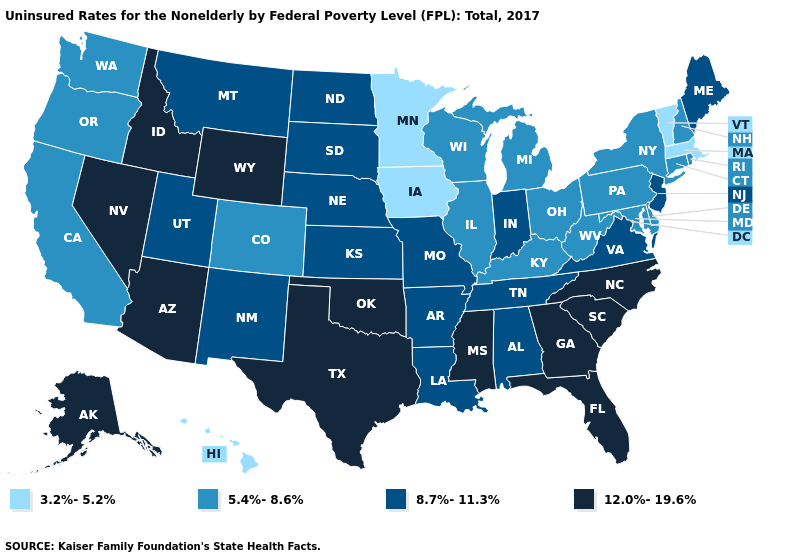What is the value of Hawaii?
Be succinct. 3.2%-5.2%. Name the states that have a value in the range 8.7%-11.3%?
Write a very short answer. Alabama, Arkansas, Indiana, Kansas, Louisiana, Maine, Missouri, Montana, Nebraska, New Jersey, New Mexico, North Dakota, South Dakota, Tennessee, Utah, Virginia. What is the highest value in the MidWest ?
Give a very brief answer. 8.7%-11.3%. Among the states that border Nebraska , does Iowa have the highest value?
Keep it brief. No. Name the states that have a value in the range 5.4%-8.6%?
Concise answer only. California, Colorado, Connecticut, Delaware, Illinois, Kentucky, Maryland, Michigan, New Hampshire, New York, Ohio, Oregon, Pennsylvania, Rhode Island, Washington, West Virginia, Wisconsin. Does Alabama have the highest value in the South?
Keep it brief. No. What is the value of Mississippi?
Be succinct. 12.0%-19.6%. Among the states that border Washington , does Idaho have the highest value?
Be succinct. Yes. Does Utah have a lower value than Florida?
Give a very brief answer. Yes. Which states have the lowest value in the West?
Answer briefly. Hawaii. What is the lowest value in the MidWest?
Write a very short answer. 3.2%-5.2%. Name the states that have a value in the range 8.7%-11.3%?
Keep it brief. Alabama, Arkansas, Indiana, Kansas, Louisiana, Maine, Missouri, Montana, Nebraska, New Jersey, New Mexico, North Dakota, South Dakota, Tennessee, Utah, Virginia. Among the states that border Missouri , does Oklahoma have the highest value?
Short answer required. Yes. How many symbols are there in the legend?
Answer briefly. 4. 